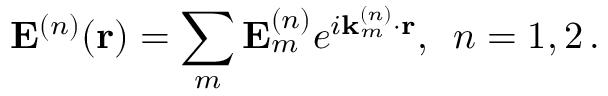<formula> <loc_0><loc_0><loc_500><loc_500>{ E } ^ { ( n ) } ( { r } ) = \sum _ { m } { E } _ { m } ^ { ( n ) } e ^ { i { k } _ { m } ^ { ( n ) } \cdot { r } } , \, n = 1 , 2 \, .</formula> 